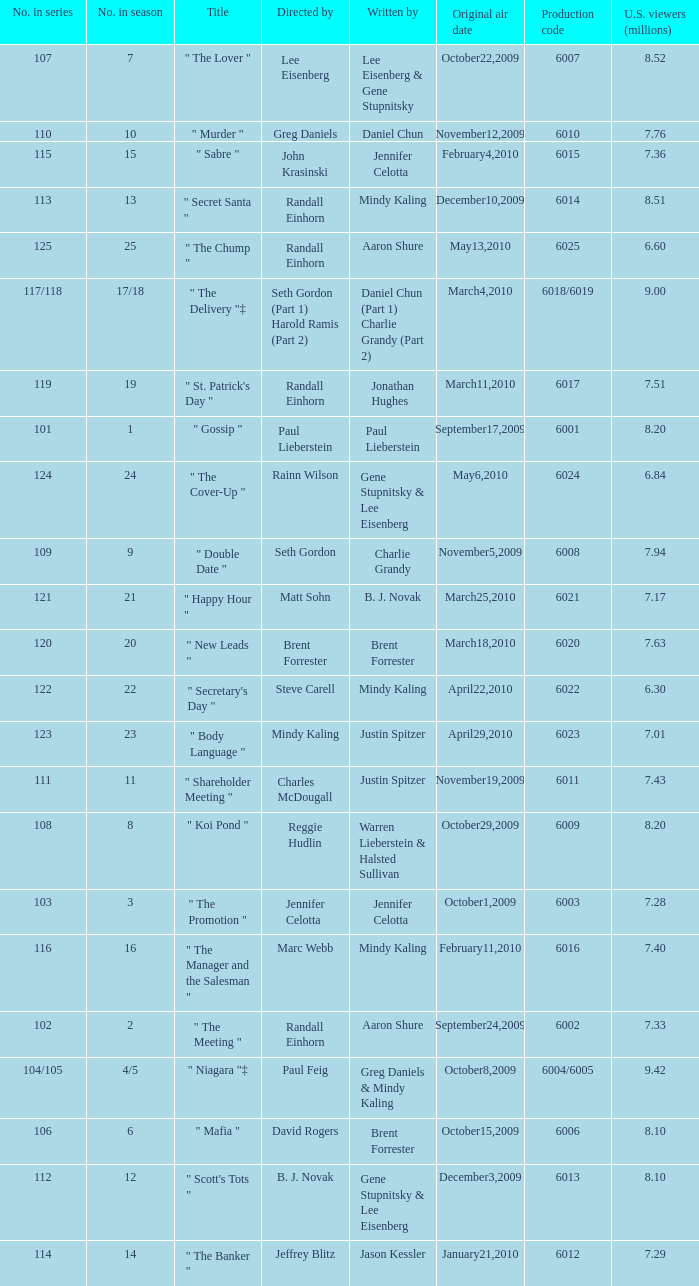Can you parse all the data within this table? {'header': ['No. in series', 'No. in season', 'Title', 'Directed by', 'Written by', 'Original air date', 'Production code', 'U.S. viewers (millions)'], 'rows': [['107', '7', '" The Lover "', 'Lee Eisenberg', 'Lee Eisenberg & Gene Stupnitsky', 'October22,2009', '6007', '8.52'], ['110', '10', '" Murder "', 'Greg Daniels', 'Daniel Chun', 'November12,2009', '6010', '7.76'], ['115', '15', '" Sabre "', 'John Krasinski', 'Jennifer Celotta', 'February4,2010', '6015', '7.36'], ['113', '13', '" Secret Santa "', 'Randall Einhorn', 'Mindy Kaling', 'December10,2009', '6014', '8.51'], ['125', '25', '" The Chump "', 'Randall Einhorn', 'Aaron Shure', 'May13,2010', '6025', '6.60'], ['117/118', '17/18', '" The Delivery "‡', 'Seth Gordon (Part 1) Harold Ramis (Part 2)', 'Daniel Chun (Part 1) Charlie Grandy (Part 2)', 'March4,2010', '6018/6019', '9.00'], ['119', '19', '" St. Patrick\'s Day "', 'Randall Einhorn', 'Jonathan Hughes', 'March11,2010', '6017', '7.51'], ['101', '1', '" Gossip "', 'Paul Lieberstein', 'Paul Lieberstein', 'September17,2009', '6001', '8.20'], ['124', '24', '" The Cover-Up "', 'Rainn Wilson', 'Gene Stupnitsky & Lee Eisenberg', 'May6,2010', '6024', '6.84'], ['109', '9', '" Double Date "', 'Seth Gordon', 'Charlie Grandy', 'November5,2009', '6008', '7.94'], ['121', '21', '" Happy Hour "', 'Matt Sohn', 'B. J. Novak', 'March25,2010', '6021', '7.17'], ['120', '20', '" New Leads "', 'Brent Forrester', 'Brent Forrester', 'March18,2010', '6020', '7.63'], ['122', '22', '" Secretary\'s Day "', 'Steve Carell', 'Mindy Kaling', 'April22,2010', '6022', '6.30'], ['123', '23', '" Body Language "', 'Mindy Kaling', 'Justin Spitzer', 'April29,2010', '6023', '7.01'], ['111', '11', '" Shareholder Meeting "', 'Charles McDougall', 'Justin Spitzer', 'November19,2009', '6011', '7.43'], ['108', '8', '" Koi Pond "', 'Reggie Hudlin', 'Warren Lieberstein & Halsted Sullivan', 'October29,2009', '6009', '8.20'], ['103', '3', '" The Promotion "', 'Jennifer Celotta', 'Jennifer Celotta', 'October1,2009', '6003', '7.28'], ['116', '16', '" The Manager and the Salesman "', 'Marc Webb', 'Mindy Kaling', 'February11,2010', '6016', '7.40'], ['102', '2', '" The Meeting "', 'Randall Einhorn', 'Aaron Shure', 'September24,2009', '6002', '7.33'], ['104/105', '4/5', '" Niagara "‡', 'Paul Feig', 'Greg Daniels & Mindy Kaling', 'October8,2009', '6004/6005', '9.42'], ['106', '6', '" Mafia "', 'David Rogers', 'Brent Forrester', 'October15,2009', '6006', '8.10'], ['112', '12', '" Scott\'s Tots "', 'B. J. Novak', 'Gene Stupnitsky & Lee Eisenberg', 'December3,2009', '6013', '8.10'], ['114', '14', '" The Banker "', 'Jeffrey Blitz', 'Jason Kessler', 'January21,2010', '6012', '7.29']]} Name the production code for number in season being 21 6021.0. 